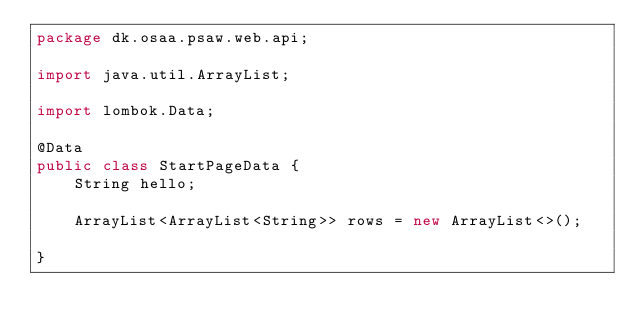Convert code to text. <code><loc_0><loc_0><loc_500><loc_500><_Java_>package dk.osaa.psaw.web.api;

import java.util.ArrayList;

import lombok.Data;

@Data
public class StartPageData {		
	String hello;
	
	ArrayList<ArrayList<String>> rows = new ArrayList<>();

}
</code> 